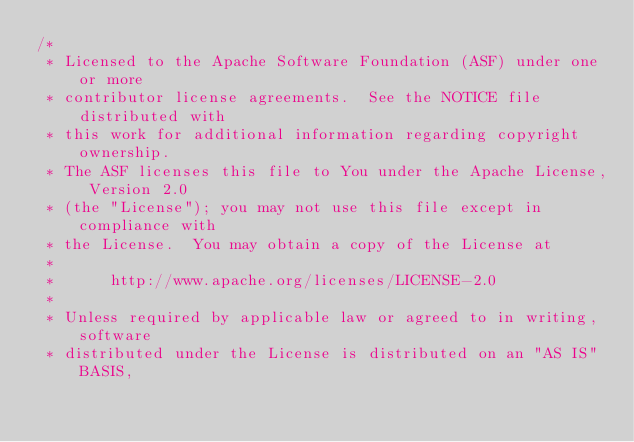<code> <loc_0><loc_0><loc_500><loc_500><_C++_>/*
 * Licensed to the Apache Software Foundation (ASF) under one or more
 * contributor license agreements.  See the NOTICE file distributed with
 * this work for additional information regarding copyright ownership.
 * The ASF licenses this file to You under the Apache License, Version 2.0
 * (the "License"); you may not use this file except in compliance with
 * the License.  You may obtain a copy of the License at
 *
 *      http://www.apache.org/licenses/LICENSE-2.0
 *
 * Unless required by applicable law or agreed to in writing, software
 * distributed under the License is distributed on an "AS IS" BASIS,</code> 